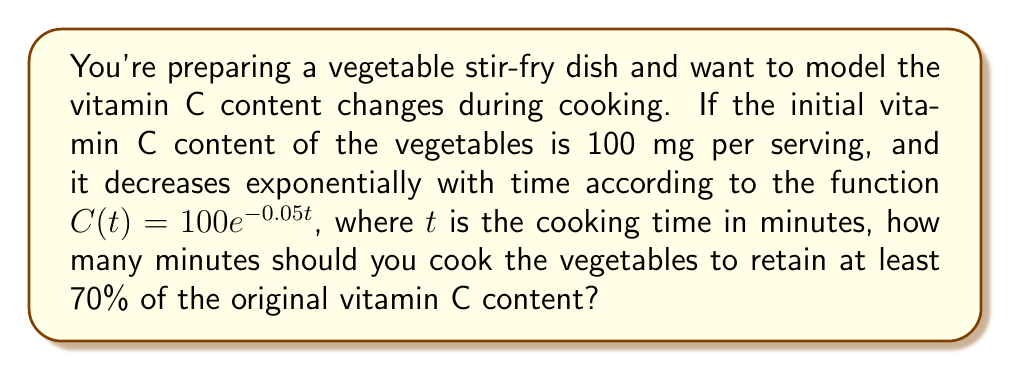Provide a solution to this math problem. Let's approach this step-by-step:

1) We want to find $t$ when $C(t)$ is 70% of the initial value.

2) 70% of 100 mg is $0.7 \times 100 = 70$ mg.

3) We can set up the equation:
   $$70 = 100e^{-0.05t}$$

4) Divide both sides by 100:
   $$0.7 = e^{-0.05t}$$

5) Take the natural logarithm of both sides:
   $$\ln(0.7) = \ln(e^{-0.05t})$$

6) Simplify the right side using the properties of logarithms:
   $$\ln(0.7) = -0.05t$$

7) Divide both sides by -0.05:
   $$\frac{\ln(0.7)}{-0.05} = t$$

8) Calculate:
   $$t = \frac{\ln(0.7)}{-0.05} \approx 7.13$$

9) Since we can't cook for a fractional minute in practice, we round down to ensure we retain at least 70% of the vitamin C.

Therefore, you should cook the vegetables for 7 minutes to retain at least 70% of the original vitamin C content.
Answer: 7 minutes 